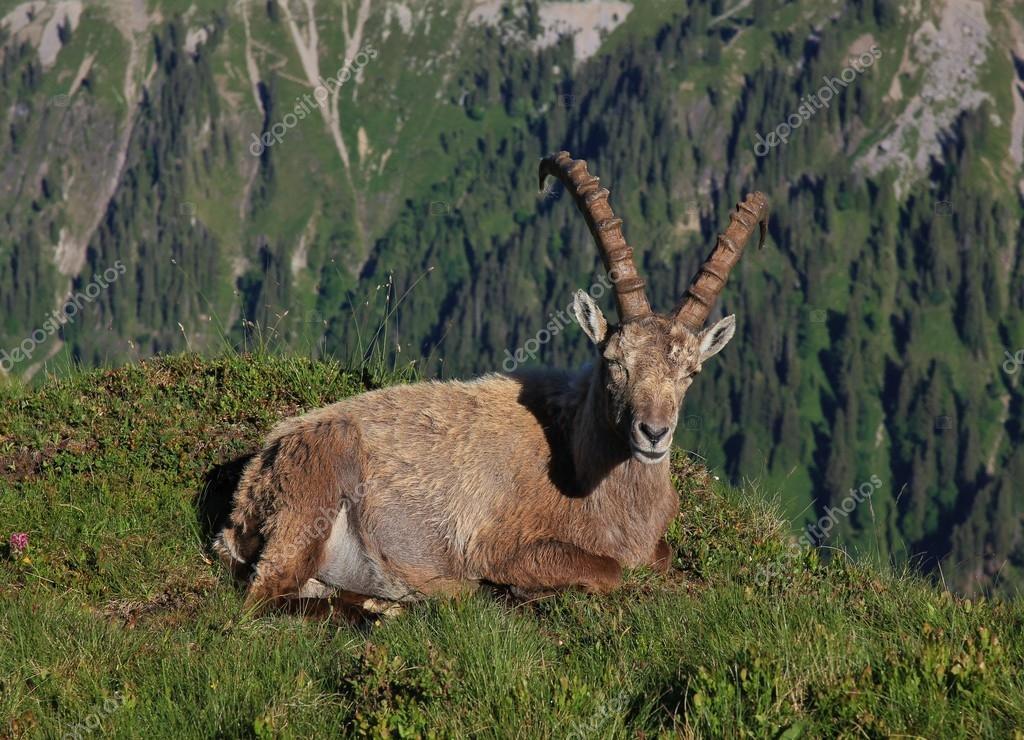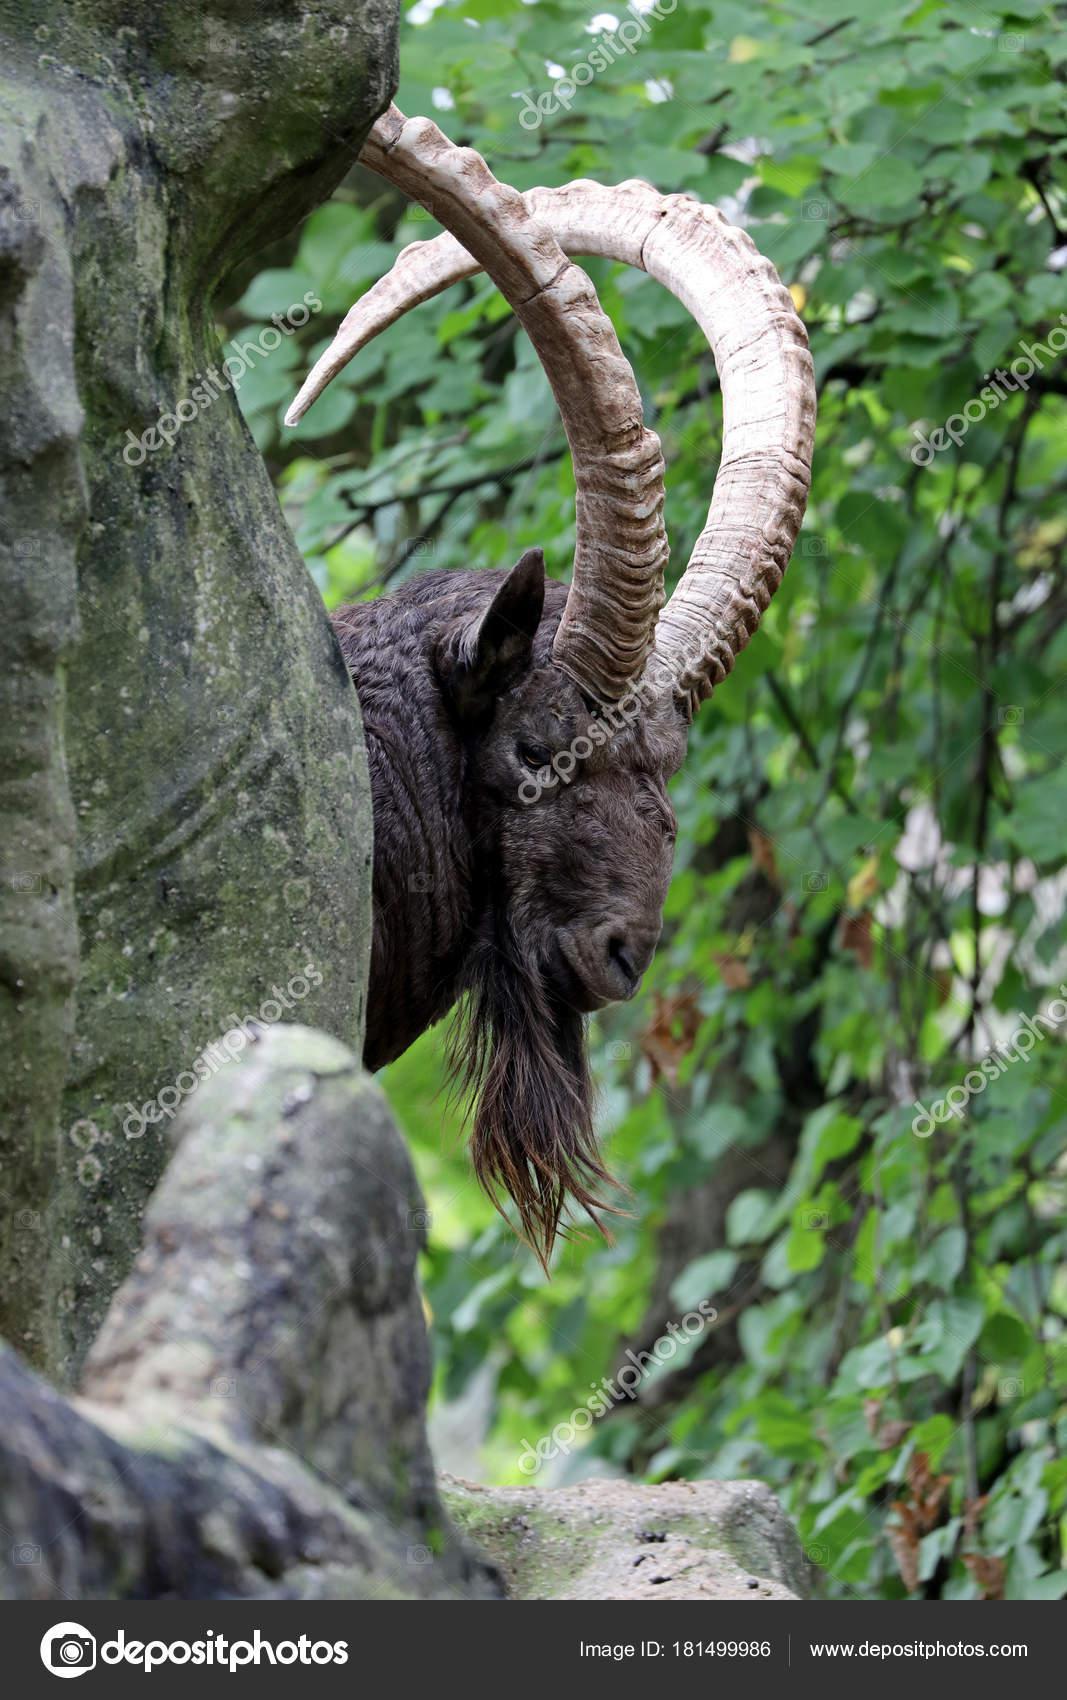The first image is the image on the left, the second image is the image on the right. Assess this claim about the two images: "The left and right image contains the same number of goats with one sitting.". Correct or not? Answer yes or no. Yes. The first image is the image on the left, the second image is the image on the right. Considering the images on both sides, is "The left image contains one reclining long-horned animal with its front legs folded under and its head turned to face the camera." valid? Answer yes or no. Yes. 